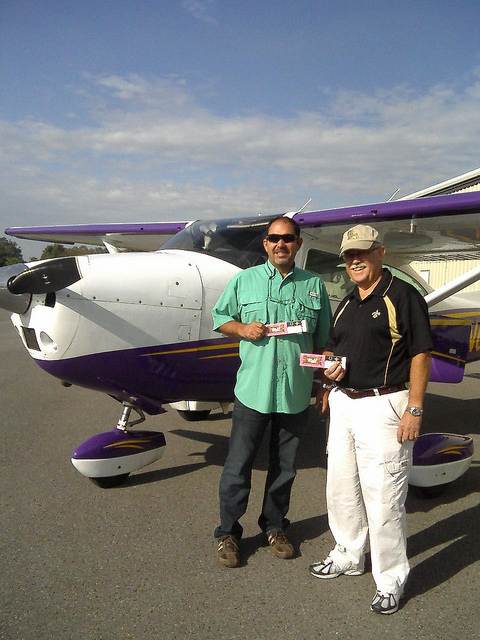What kind of activity could the people be engaged in here? The individuals in the image might be engaged in recreational flying, a flying lesson, or possibly returning from a trip. The relaxed body language and smiles suggest a leisure activity or successful completion of a flight. They are also exchanging what appears to be a certificate or license, which might indicate the completion of a flight training course or a congratulatory event.  Do you notice anything interesting about the environment? The environment around the aircraft is a flat, open tarmac, which is conducive to aircraft operations. The image is captured during what seems to be daytime under a partly cloudy sky, with no visible adverse weather conditions. These are favorable conditions for flying. The absence of other airplanes in the immediate vicinity suggests a quieter airfield, which could indicate a private or less busy regional airport. 